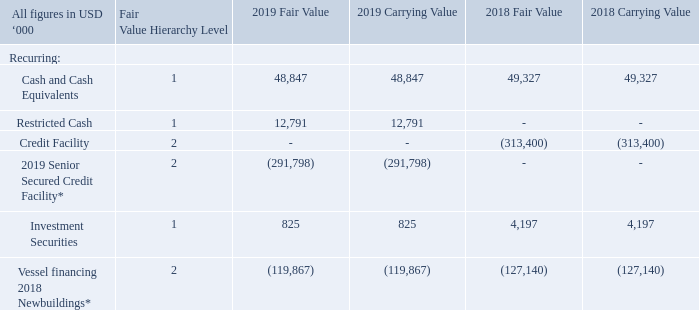16. FINANCIAL INSTRUMENTS AND OTHER FAIR VALUE DISCLOSURES
The majority of NAT and its subsidiaries’ transactions, assets and liabilities are denominated in United States dollars, the functional currency of the Company. There is no significant risk that currency fluctuations will have a negative effect on the value of the Company’s cash flows.
The Company categorizes its fair value estimates using a fair value hierarchy based on the inputs used to measure fair value for those assets that are recorded on the Balance Sheet at fair value. The fair value hierarchy has three levels based on the reliability of the inputs used to determine fair value as follows:
Level 1. Quoted prices (unadjusted) in active markets for identical assets or liabilities that the reporting entity can access at the measurement date.
Level 2. Inputs, other than the quoted prices in active markets, that are observable either directly or indirectly; and
Level 3. Unobservable inputs in which there is little or no market data, which require the reporting entity to develop its own assumptions.
The following methods and assumptions were used to estimate the fair value of each class of financial instruments and other financial assets.
-  The carrying value of cash and cash equivalents and marketable securities, is a reasonable estimate of fair value.
-  The estimated fair value for the long-term debt is considered to be equal to the carrying values since it bears spreads and variable interest rates which approximate market rates.
The carrying value and estimated fair value of the Company`s financial instruments at December 31, 2019 and 2018, are as follows:
* The 2019 Senior Secured Credit Facility and Vessel financing 2018 Newbuildings carry a floating LIBOR interest rate, plus a margin and the fair value is assumed to equal the carrying value.
What are the respective 2018 and 2019 fair value of the company's cash and cash equivalents? 49,327, 48,847. What are the respective 2018 and 2019 fair value of the company's investment securities? 4,197, 825. What are the respective 2018 and 2019 fair value of the company's vessel financing 2018 newbuildings? (127,140), (119,867). What is the average value of the 2018 and 2019 fair value of the company's cash and cash equivalents? (49,327 + 48,847)/2 
Answer: 49087. What is the average value of the 2018 and 2019 fair value of the company's investment securities? (4,197 + 825)/2 
Answer: 2511. What is the average value of the 2018 and 2019 fair value of the company's vessel financing 2018 newbuildings? (127,140 + 119,867)/2 
Answer: 123503.5. 